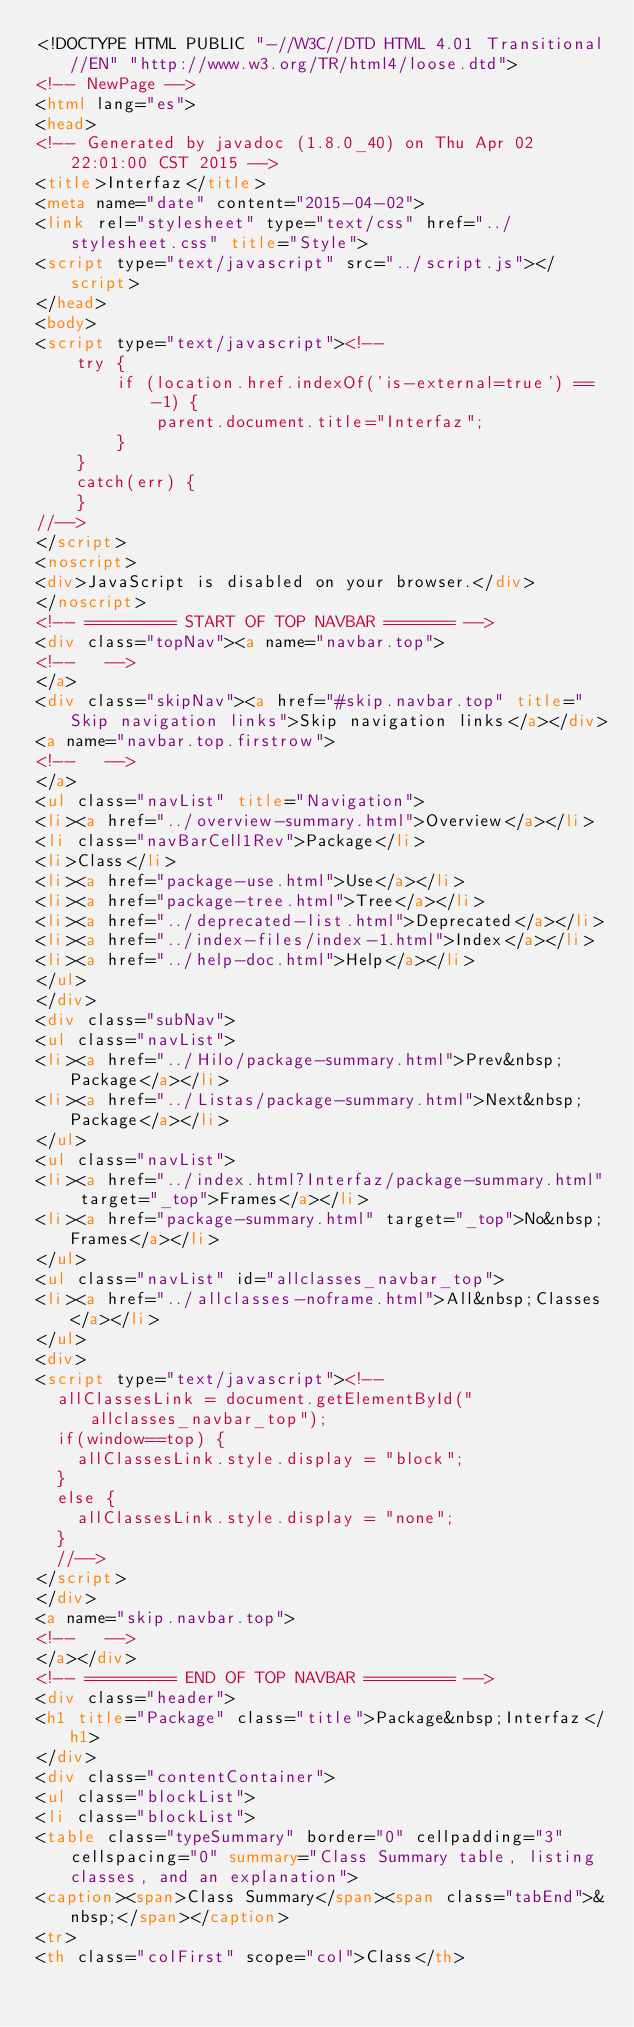Convert code to text. <code><loc_0><loc_0><loc_500><loc_500><_HTML_><!DOCTYPE HTML PUBLIC "-//W3C//DTD HTML 4.01 Transitional//EN" "http://www.w3.org/TR/html4/loose.dtd">
<!-- NewPage -->
<html lang="es">
<head>
<!-- Generated by javadoc (1.8.0_40) on Thu Apr 02 22:01:00 CST 2015 -->
<title>Interfaz</title>
<meta name="date" content="2015-04-02">
<link rel="stylesheet" type="text/css" href="../stylesheet.css" title="Style">
<script type="text/javascript" src="../script.js"></script>
</head>
<body>
<script type="text/javascript"><!--
    try {
        if (location.href.indexOf('is-external=true') == -1) {
            parent.document.title="Interfaz";
        }
    }
    catch(err) {
    }
//-->
</script>
<noscript>
<div>JavaScript is disabled on your browser.</div>
</noscript>
<!-- ========= START OF TOP NAVBAR ======= -->
<div class="topNav"><a name="navbar.top">
<!--   -->
</a>
<div class="skipNav"><a href="#skip.navbar.top" title="Skip navigation links">Skip navigation links</a></div>
<a name="navbar.top.firstrow">
<!--   -->
</a>
<ul class="navList" title="Navigation">
<li><a href="../overview-summary.html">Overview</a></li>
<li class="navBarCell1Rev">Package</li>
<li>Class</li>
<li><a href="package-use.html">Use</a></li>
<li><a href="package-tree.html">Tree</a></li>
<li><a href="../deprecated-list.html">Deprecated</a></li>
<li><a href="../index-files/index-1.html">Index</a></li>
<li><a href="../help-doc.html">Help</a></li>
</ul>
</div>
<div class="subNav">
<ul class="navList">
<li><a href="../Hilo/package-summary.html">Prev&nbsp;Package</a></li>
<li><a href="../Listas/package-summary.html">Next&nbsp;Package</a></li>
</ul>
<ul class="navList">
<li><a href="../index.html?Interfaz/package-summary.html" target="_top">Frames</a></li>
<li><a href="package-summary.html" target="_top">No&nbsp;Frames</a></li>
</ul>
<ul class="navList" id="allclasses_navbar_top">
<li><a href="../allclasses-noframe.html">All&nbsp;Classes</a></li>
</ul>
<div>
<script type="text/javascript"><!--
  allClassesLink = document.getElementById("allclasses_navbar_top");
  if(window==top) {
    allClassesLink.style.display = "block";
  }
  else {
    allClassesLink.style.display = "none";
  }
  //-->
</script>
</div>
<a name="skip.navbar.top">
<!--   -->
</a></div>
<!-- ========= END OF TOP NAVBAR ========= -->
<div class="header">
<h1 title="Package" class="title">Package&nbsp;Interfaz</h1>
</div>
<div class="contentContainer">
<ul class="blockList">
<li class="blockList">
<table class="typeSummary" border="0" cellpadding="3" cellspacing="0" summary="Class Summary table, listing classes, and an explanation">
<caption><span>Class Summary</span><span class="tabEnd">&nbsp;</span></caption>
<tr>
<th class="colFirst" scope="col">Class</th></code> 